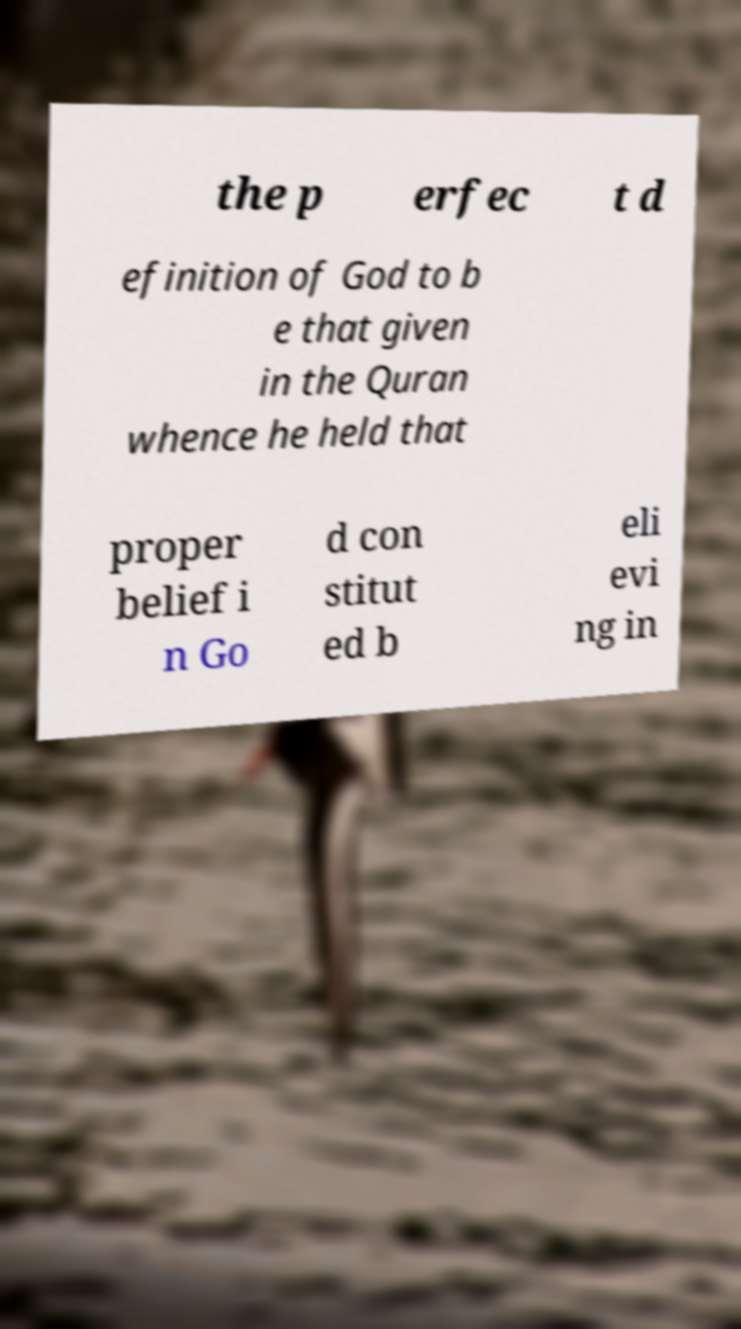Please identify and transcribe the text found in this image. the p erfec t d efinition of God to b e that given in the Quran whence he held that proper belief i n Go d con stitut ed b eli evi ng in 